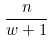<formula> <loc_0><loc_0><loc_500><loc_500>\frac { n } { w + 1 }</formula> 